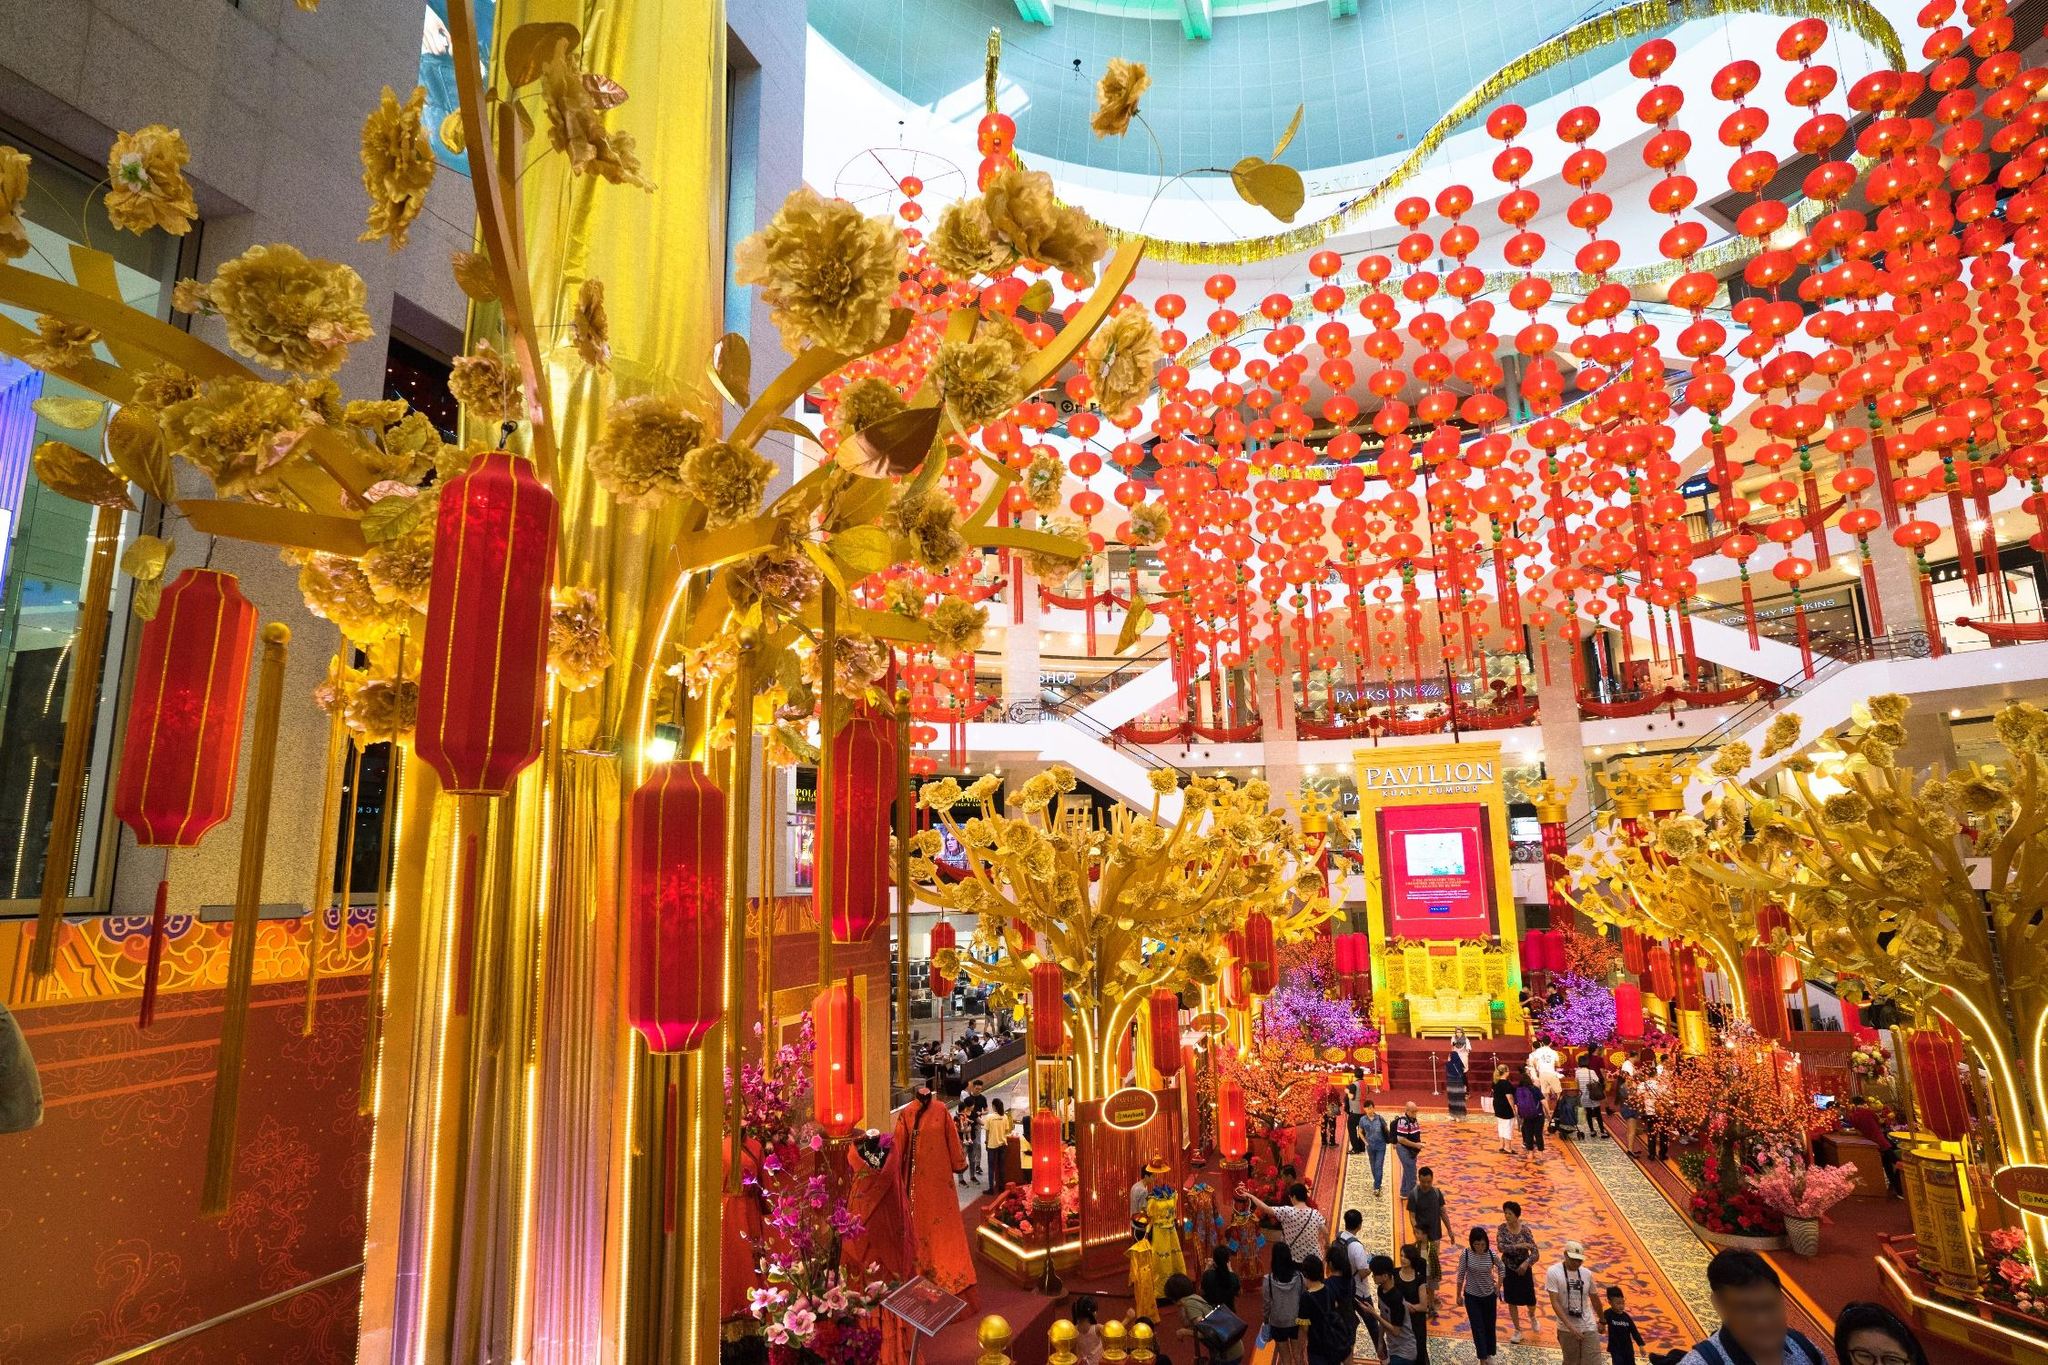Describe the following image. The image depicts a vibrant and festive atmosphere inside a shopping mall, likely celebrating a significant cultural festival, suggested by the profusion of red and gold colors. These colors are traditionally auspicious in many Asian contexts, symbolizing luck and prosperity. The mall is embellished with numerous red lanterns hanging from the ceiling and golden trees that are artistically decorated, which adds to the celebratory feel. Shoppers can be seen enjoying the environment, adding a lively human element to the scene. This setting could be part of a New Year or mid-autumn festival celebration, which are popular in various Asian cultures. 